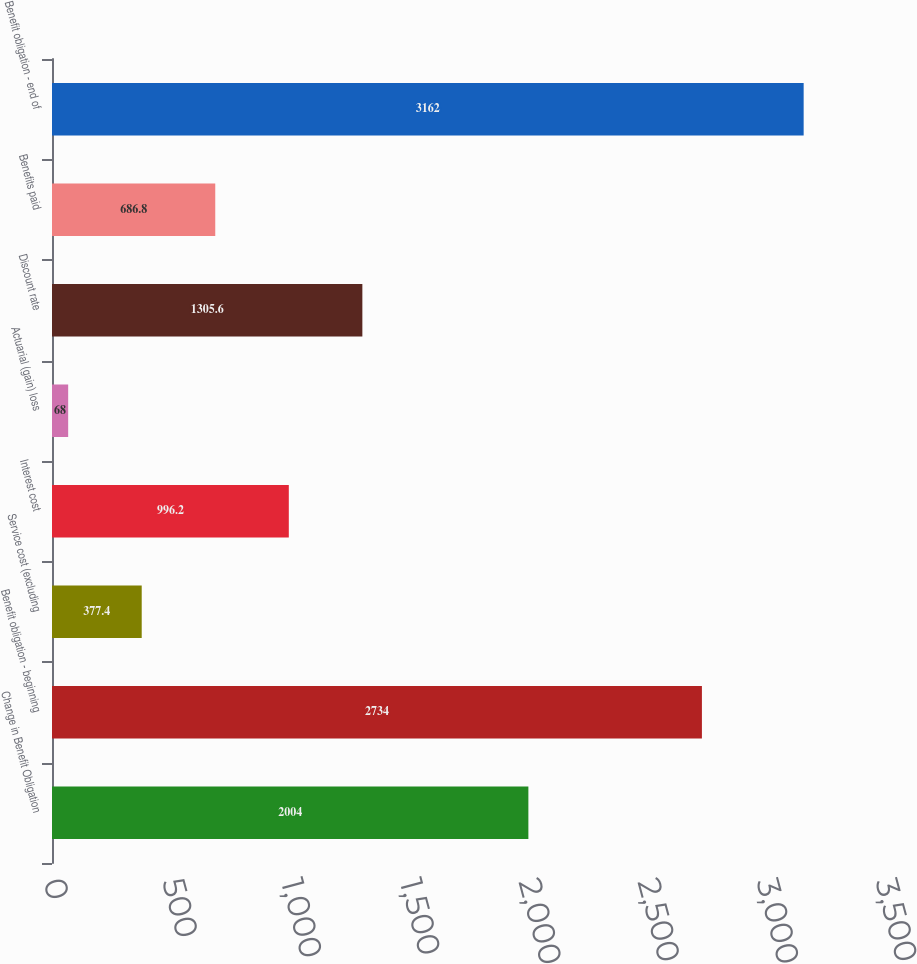Convert chart. <chart><loc_0><loc_0><loc_500><loc_500><bar_chart><fcel>Change in Benefit Obligation<fcel>Benefit obligation - beginning<fcel>Service cost (excluding<fcel>Interest cost<fcel>Actuarial (gain) loss<fcel>Discount rate<fcel>Benefits paid<fcel>Benefit obligation - end of<nl><fcel>2004<fcel>2734<fcel>377.4<fcel>996.2<fcel>68<fcel>1305.6<fcel>686.8<fcel>3162<nl></chart> 